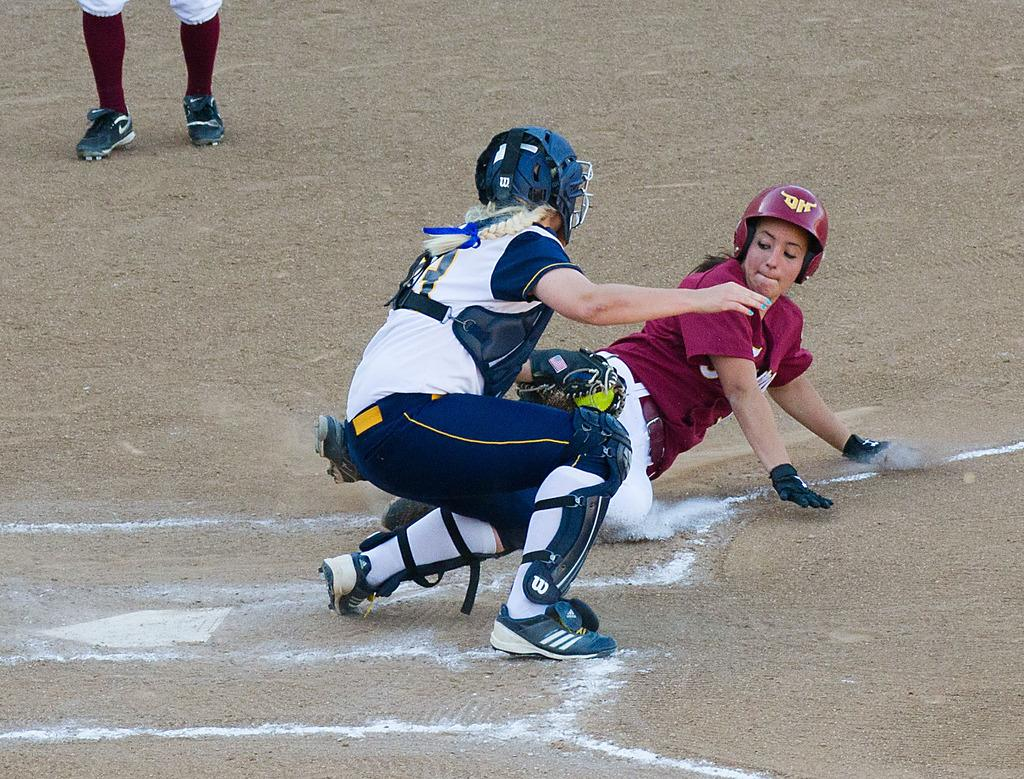How many people are in the image? There are two persons in the image. What protective gear are the persons wearing? Both persons are wearing helmets and gloves. Does the person in the front have any additional protective gear? Yes, the person in the front is wearing knee pads. What can be seen of the person in the back? The legs of the person in the back are visible. Where are the persons located? They are on a ground. What type of class is the tiger attending in the image? There is no tiger present in the image, so it is not possible to determine what class they might be attending. 